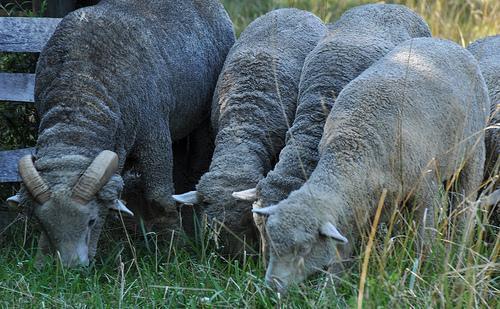How many sheep have horns?
Give a very brief answer. 1. How many open eyes are pictured?
Give a very brief answer. 1. 